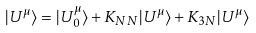Convert formula to latex. <formula><loc_0><loc_0><loc_500><loc_500>| U ^ { \mu } \rangle = | U _ { 0 } ^ { \mu } \rangle + K _ { N N } | U ^ { \mu } \rangle + K _ { 3 N } | U ^ { \mu } \rangle</formula> 